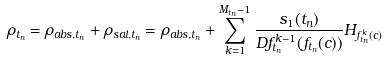Convert formula to latex. <formula><loc_0><loc_0><loc_500><loc_500>\rho _ { t _ { n } } = \rho _ { a b s , t _ { n } } + \rho _ { s a l , t _ { n } } = \rho _ { a b s , t _ { n } } + \sum _ { k = 1 } ^ { M _ { t _ { n } } - 1 } \frac { s _ { 1 } ( t _ { n } ) } { D f ^ { k - 1 } _ { t _ { n } } ( f _ { t _ { n } } ( c ) ) } H _ { f ^ { k } _ { t _ { n } } ( c ) }</formula> 